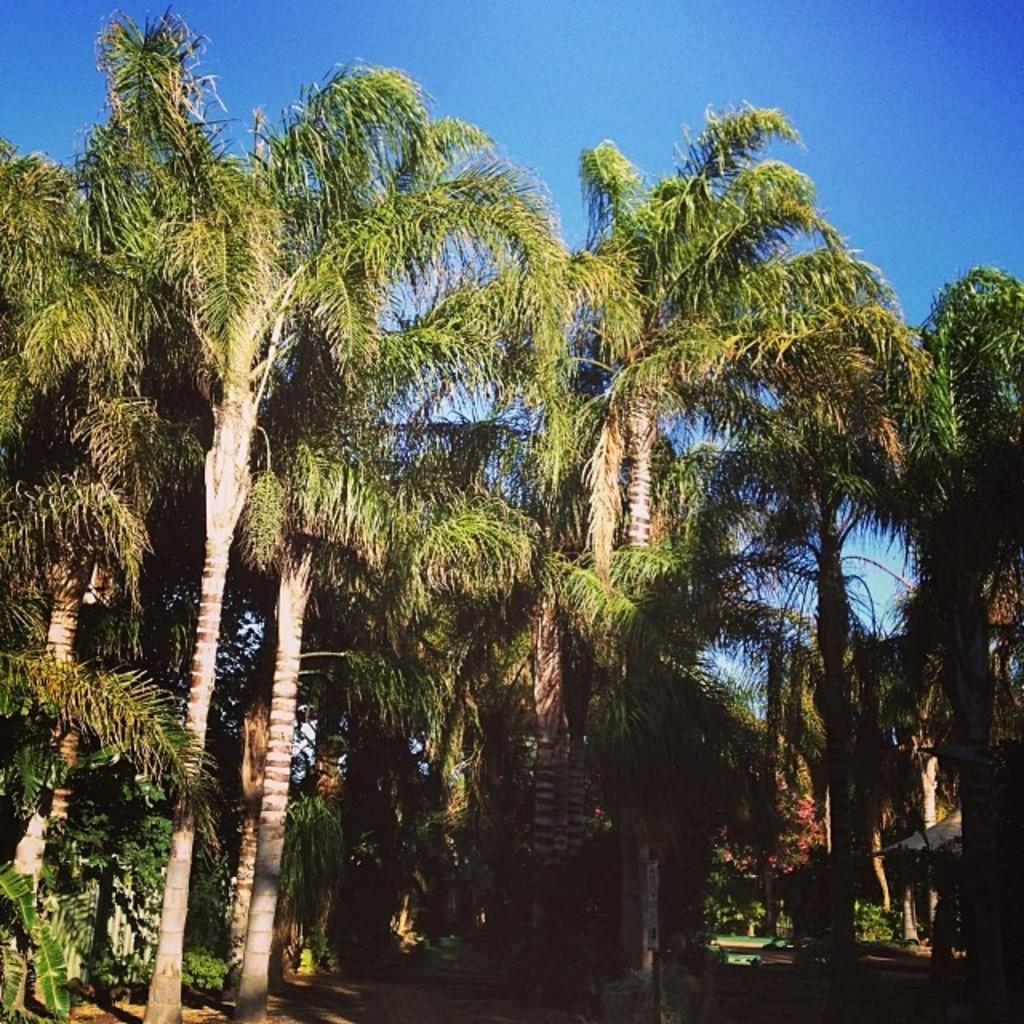What is the possible location from where the image was taken? The image might be taken from outside of the city. What type of vegetation can be seen in the image? There are palm trees in the image. What is visible at the top of the image? The sky is visible at the top of the image. What type of mint is growing near the palm trees in the image? There is no mint visible in the image; only palm trees are mentioned. 